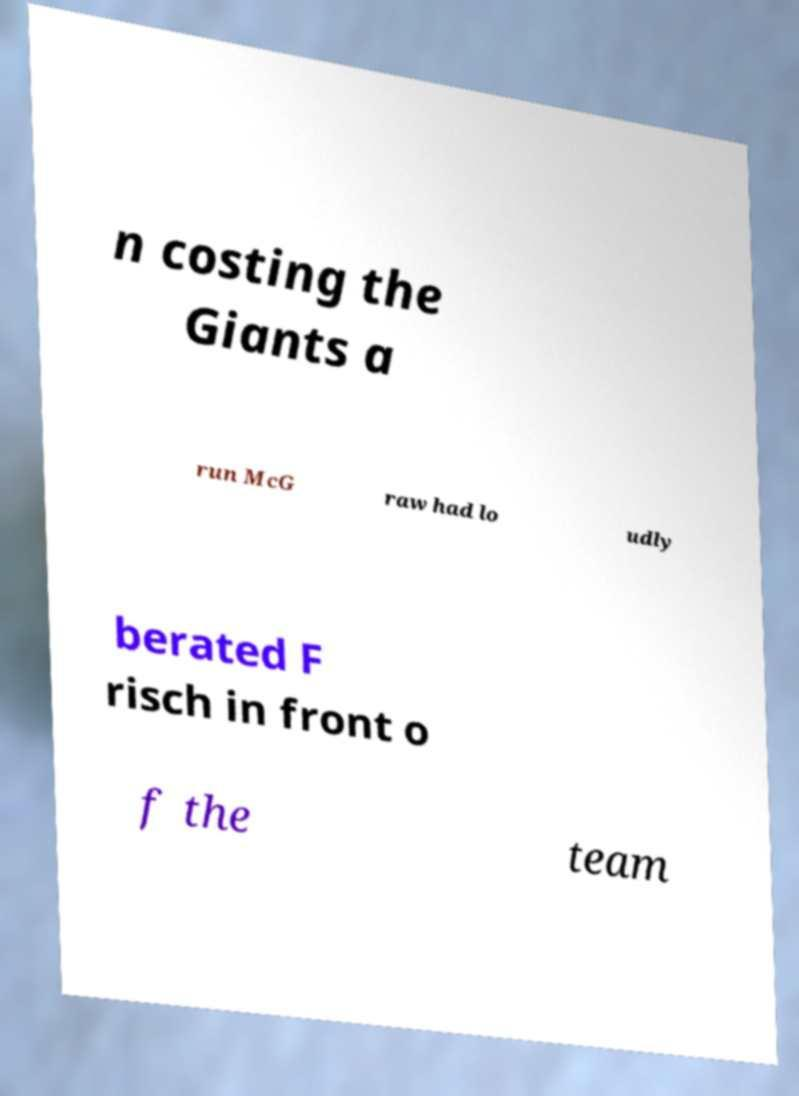Could you assist in decoding the text presented in this image and type it out clearly? n costing the Giants a run McG raw had lo udly berated F risch in front o f the team 